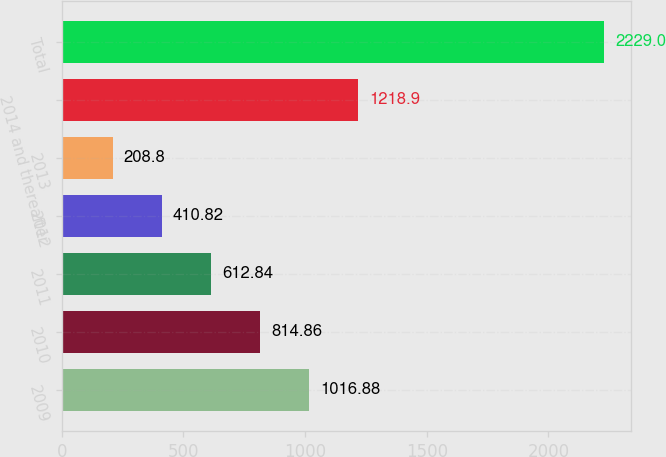Convert chart to OTSL. <chart><loc_0><loc_0><loc_500><loc_500><bar_chart><fcel>2009<fcel>2010<fcel>2011<fcel>2012<fcel>2013<fcel>2014 and thereafter<fcel>Total<nl><fcel>1016.88<fcel>814.86<fcel>612.84<fcel>410.82<fcel>208.8<fcel>1218.9<fcel>2229<nl></chart> 